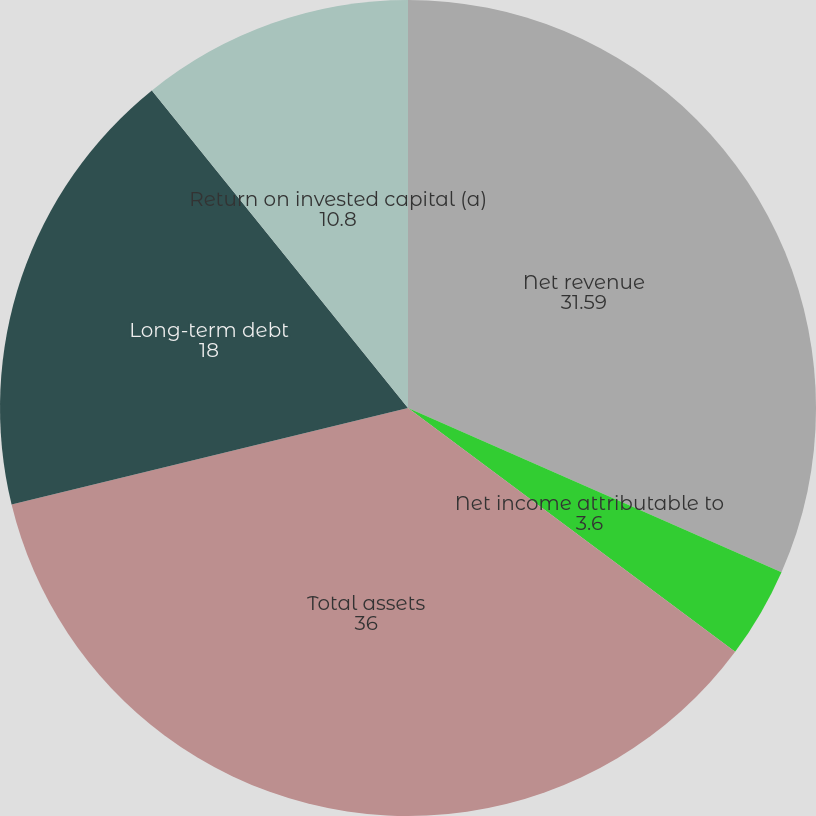Convert chart to OTSL. <chart><loc_0><loc_0><loc_500><loc_500><pie_chart><fcel>Net revenue<fcel>Net income attributable to<fcel>Cash dividends declared per<fcel>Total assets<fcel>Long-term debt<fcel>Return on invested capital (a)<nl><fcel>31.59%<fcel>3.6%<fcel>0.0%<fcel>36.0%<fcel>18.0%<fcel>10.8%<nl></chart> 